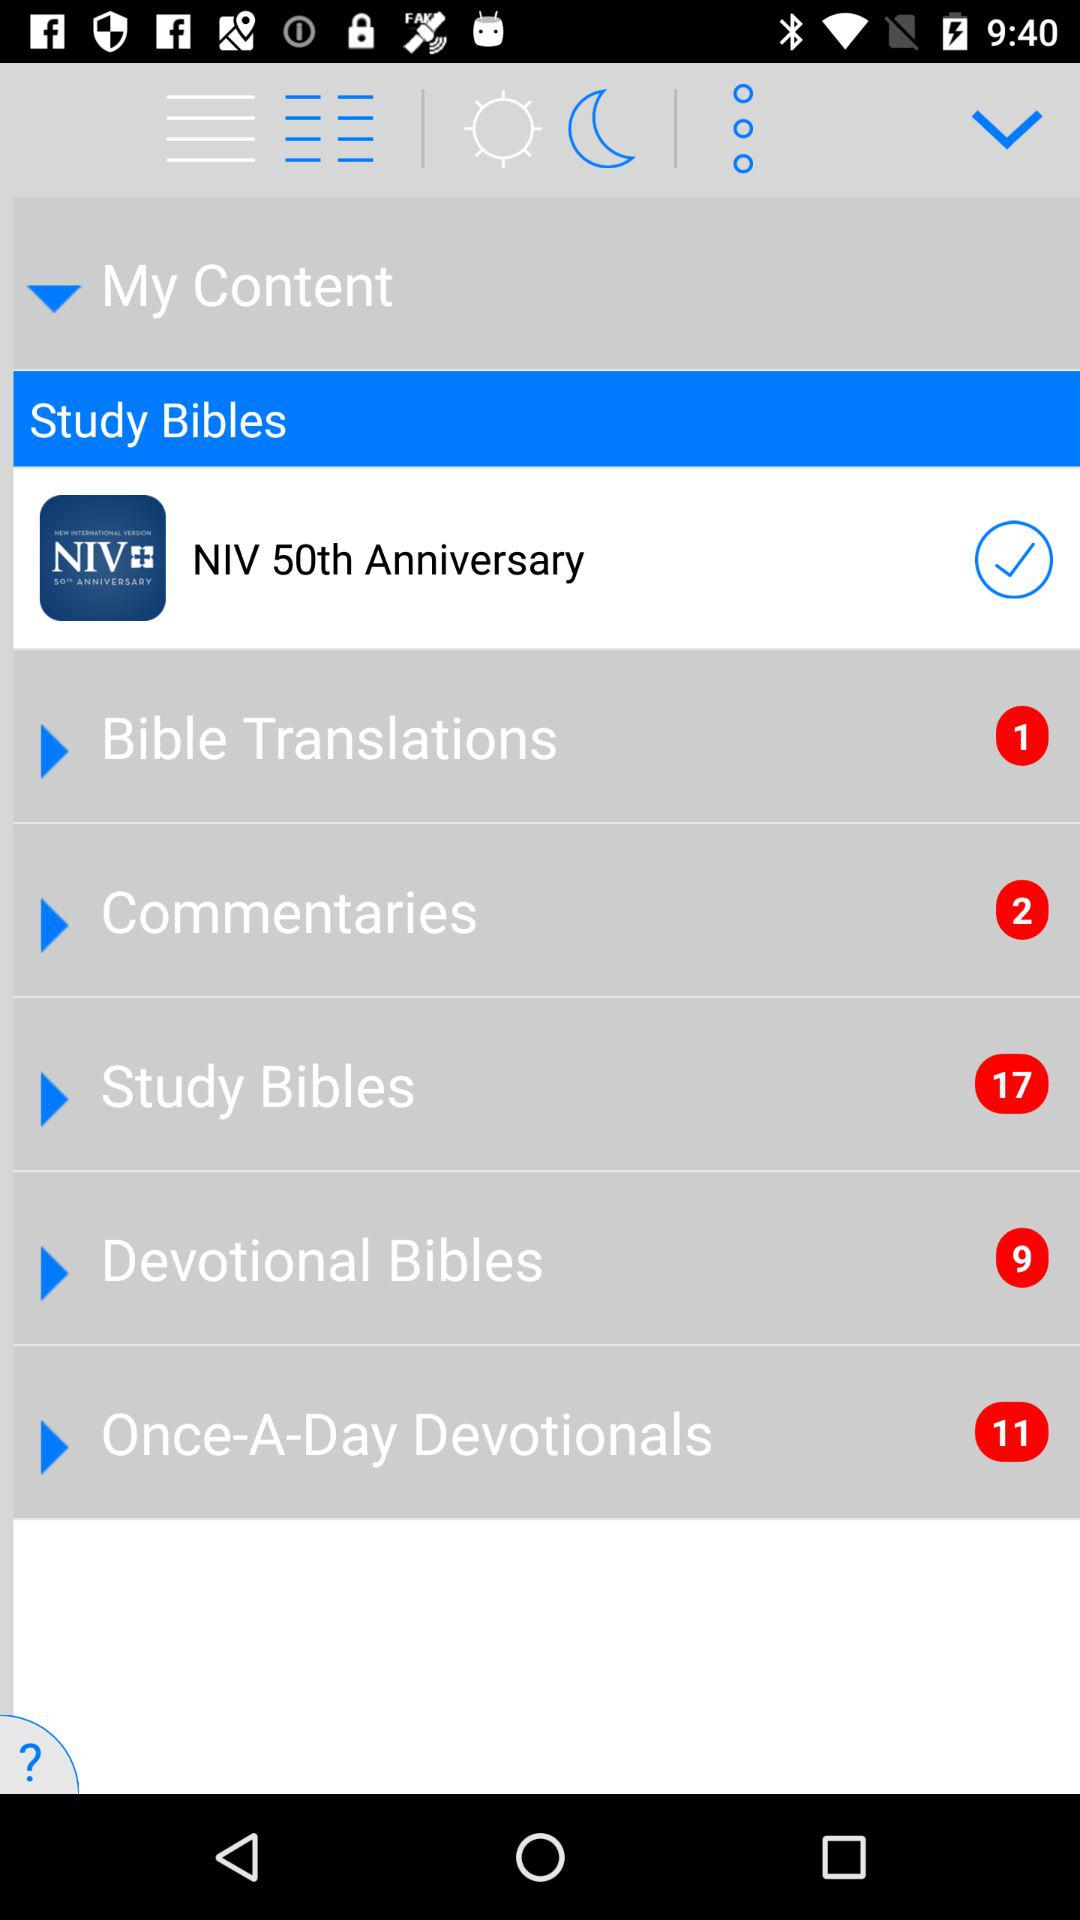How many notifications are pending in "Study Bibles"? There are 17 pending notifications in "Study Bibles". 